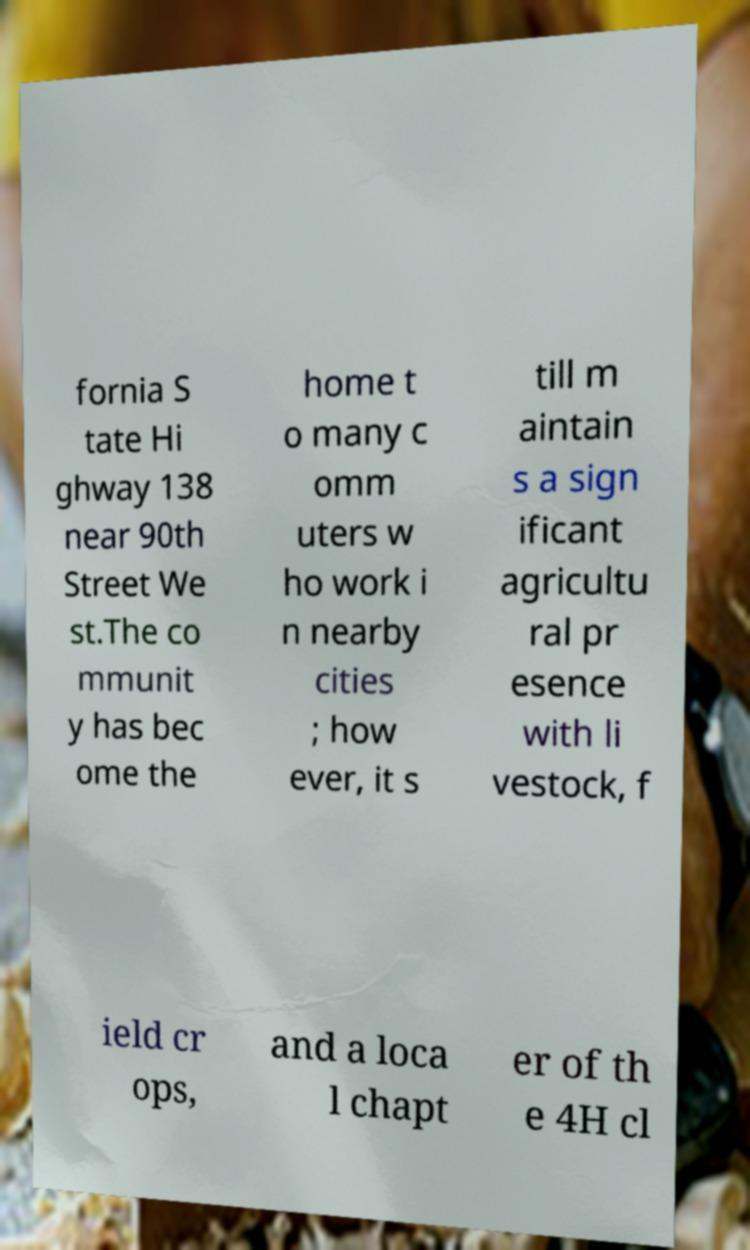There's text embedded in this image that I need extracted. Can you transcribe it verbatim? fornia S tate Hi ghway 138 near 90th Street We st.The co mmunit y has bec ome the home t o many c omm uters w ho work i n nearby cities ; how ever, it s till m aintain s a sign ificant agricultu ral pr esence with li vestock, f ield cr ops, and a loca l chapt er of th e 4H cl 